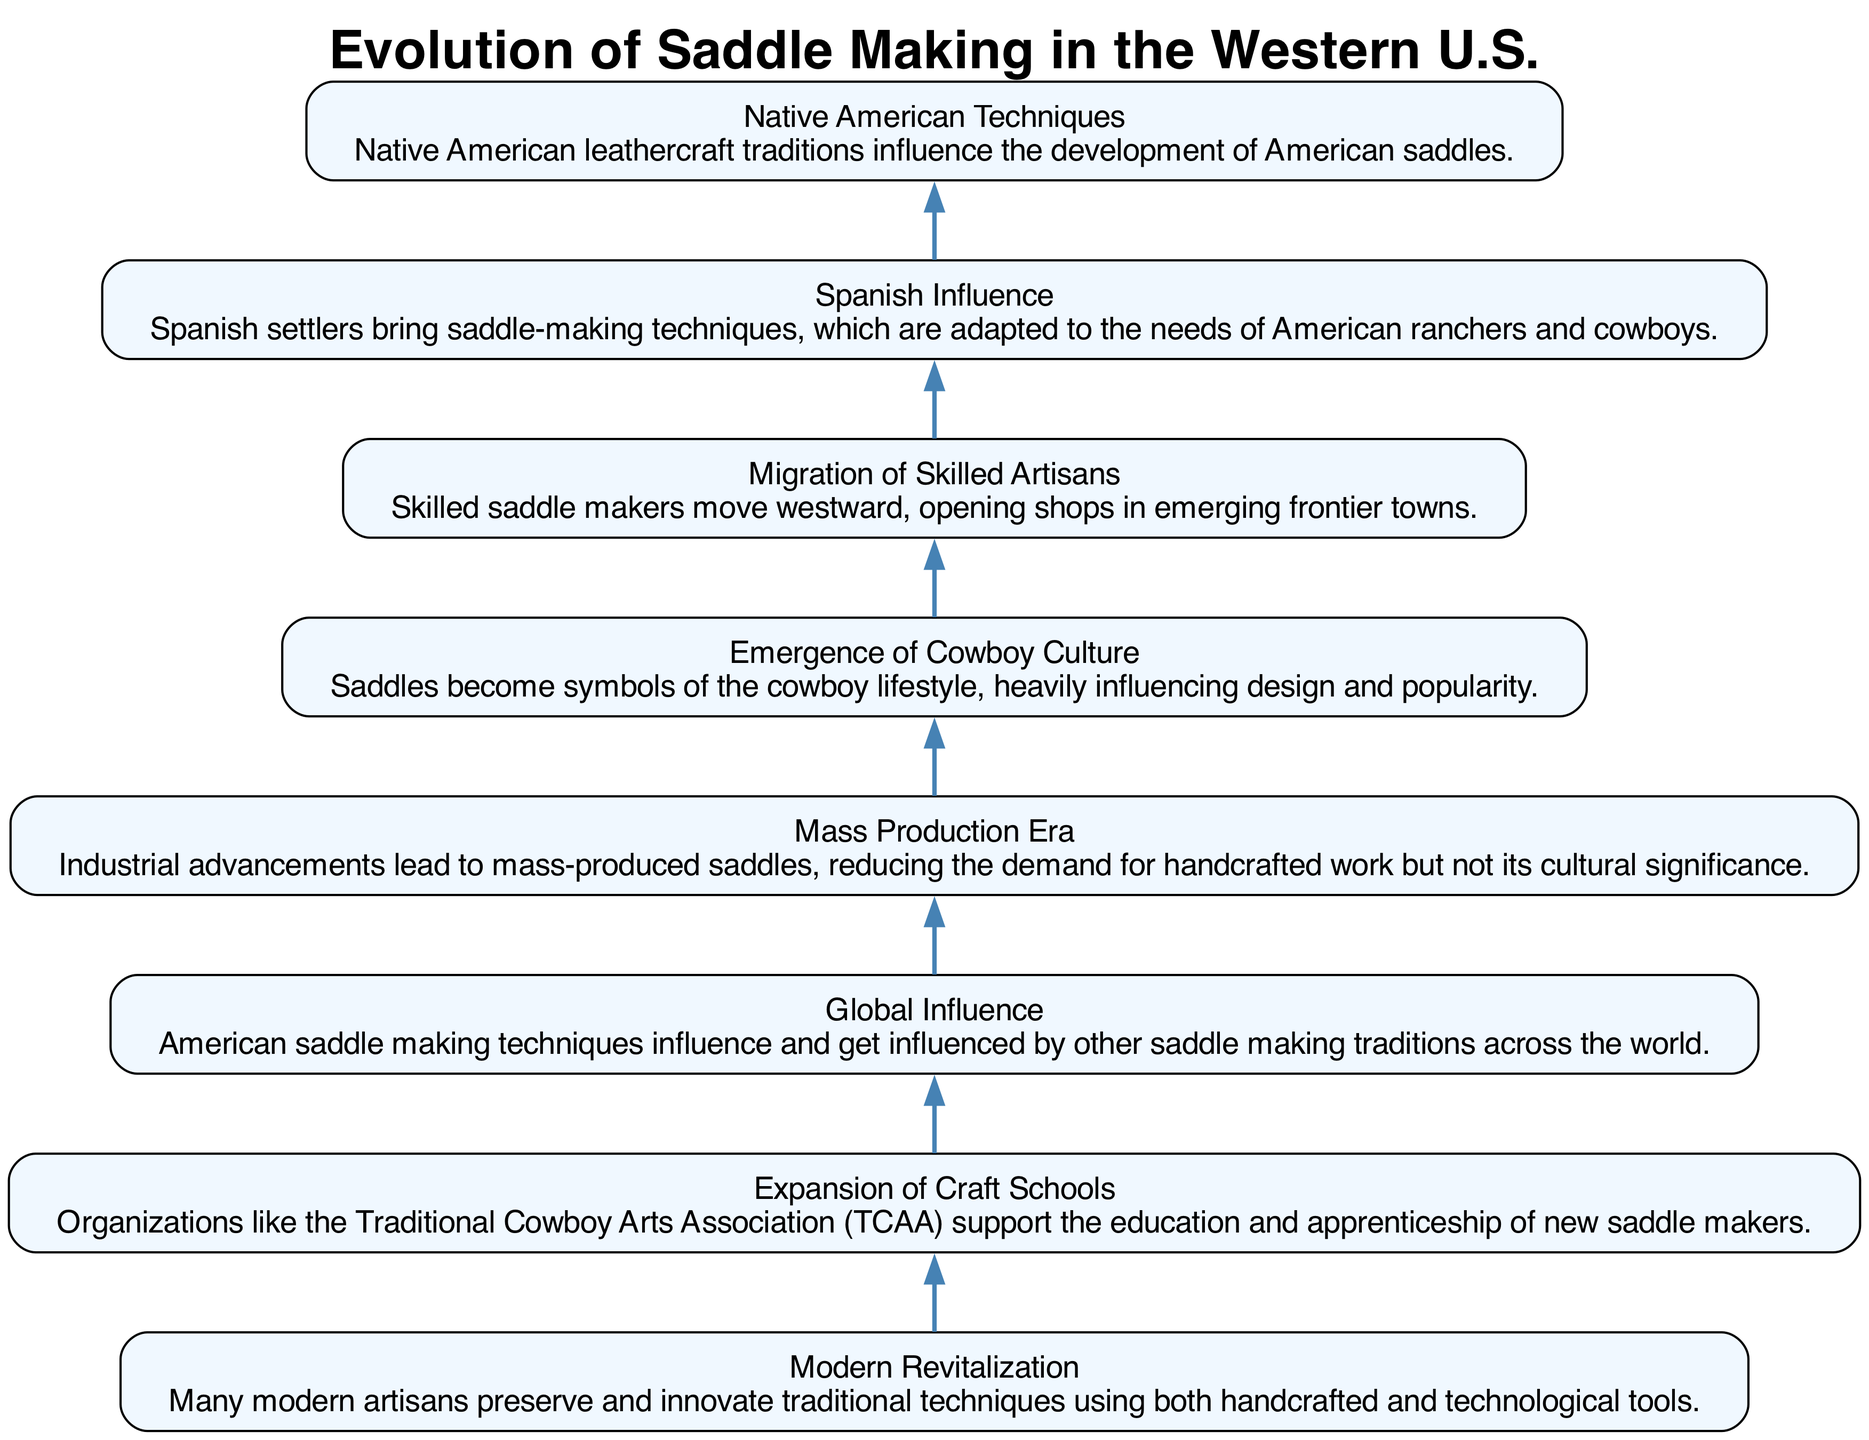What is the first step in the diagram? The first step in the diagram is "Native American Techniques." It is located at the bottom of the flowchart, indicating it is the earliest influencing factor in the evolution of saddle making.
Answer: Native American Techniques How many nodes are present in the diagram? There are eight steps listed in the dataset, which corresponds to eight nodes in the diagram. Each step represents a significant development in saddle making.
Answer: Eight What is the last step in the flowchart? The last step is "Modern Revitalization," which sits at the top of the diagram, signifying a contemporary phase in the craft's evolution.
Answer: Modern Revitalization Which step follows "Mass Production Era"? The step that follows "Mass Production Era" is "Emergence of Cowboy Culture," indicating that cowboy culture emerged after the industrialization of saddle production.
Answer: Emergence of Cowboy Culture What influences saddle making globally according to the diagram? The influence on saddle making is referred to as "Global Influence," indicating that American techniques are both influenced by and influence international saddle making practices.
Answer: Global Influence What two cultures are noted for their influence in the earlier steps? The two cultures noted for their influence on saddle making are "Spanish Influence" and "Native American Techniques," highlighting the effects of indigenous and settler traditions.
Answer: Spanish Influence, Native American Techniques Which step directly precedes the "Mass Production Era"? The step directly preceding the "Mass Production Era" is "Migration of Skilled Artisans." This indicates that skilled craftsmen were moving into new areas before the industrial production began.
Answer: Migration of Skilled Artisans How does the "Expansion of Craft Schools" affect saddle making? The "Expansion of Craft Schools" step implies that organizations support education and apprenticeships, leading to a growth in new saddle makers who continue the craft.
Answer: Education and Apprenticeships 